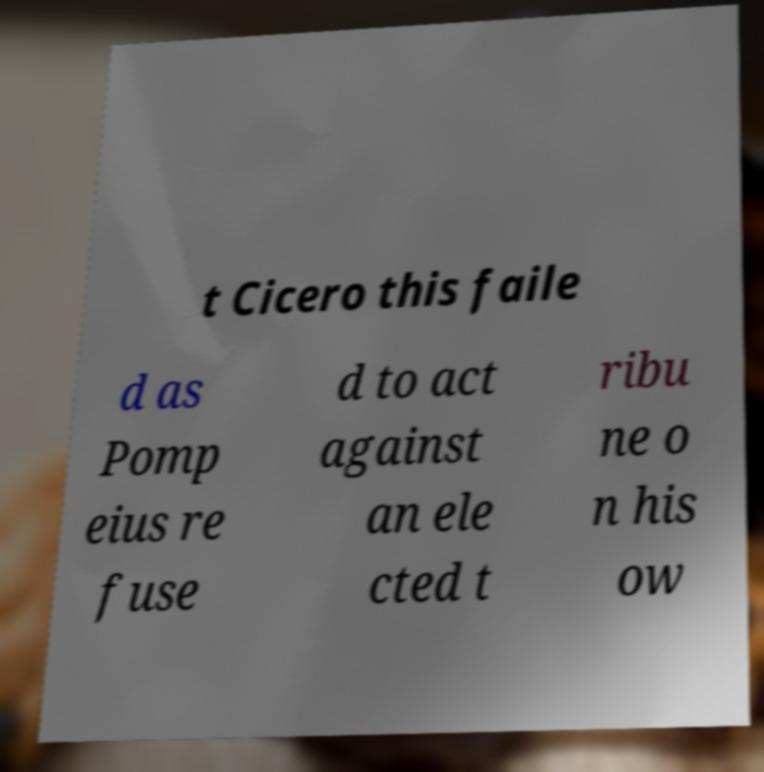I need the written content from this picture converted into text. Can you do that? t Cicero this faile d as Pomp eius re fuse d to act against an ele cted t ribu ne o n his ow 